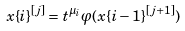<formula> <loc_0><loc_0><loc_500><loc_500>x \{ i \} ^ { [ j ] } = t ^ { \mu _ { i } } \varphi ( x \{ i - 1 \} ^ { [ j + 1 ] } )</formula> 